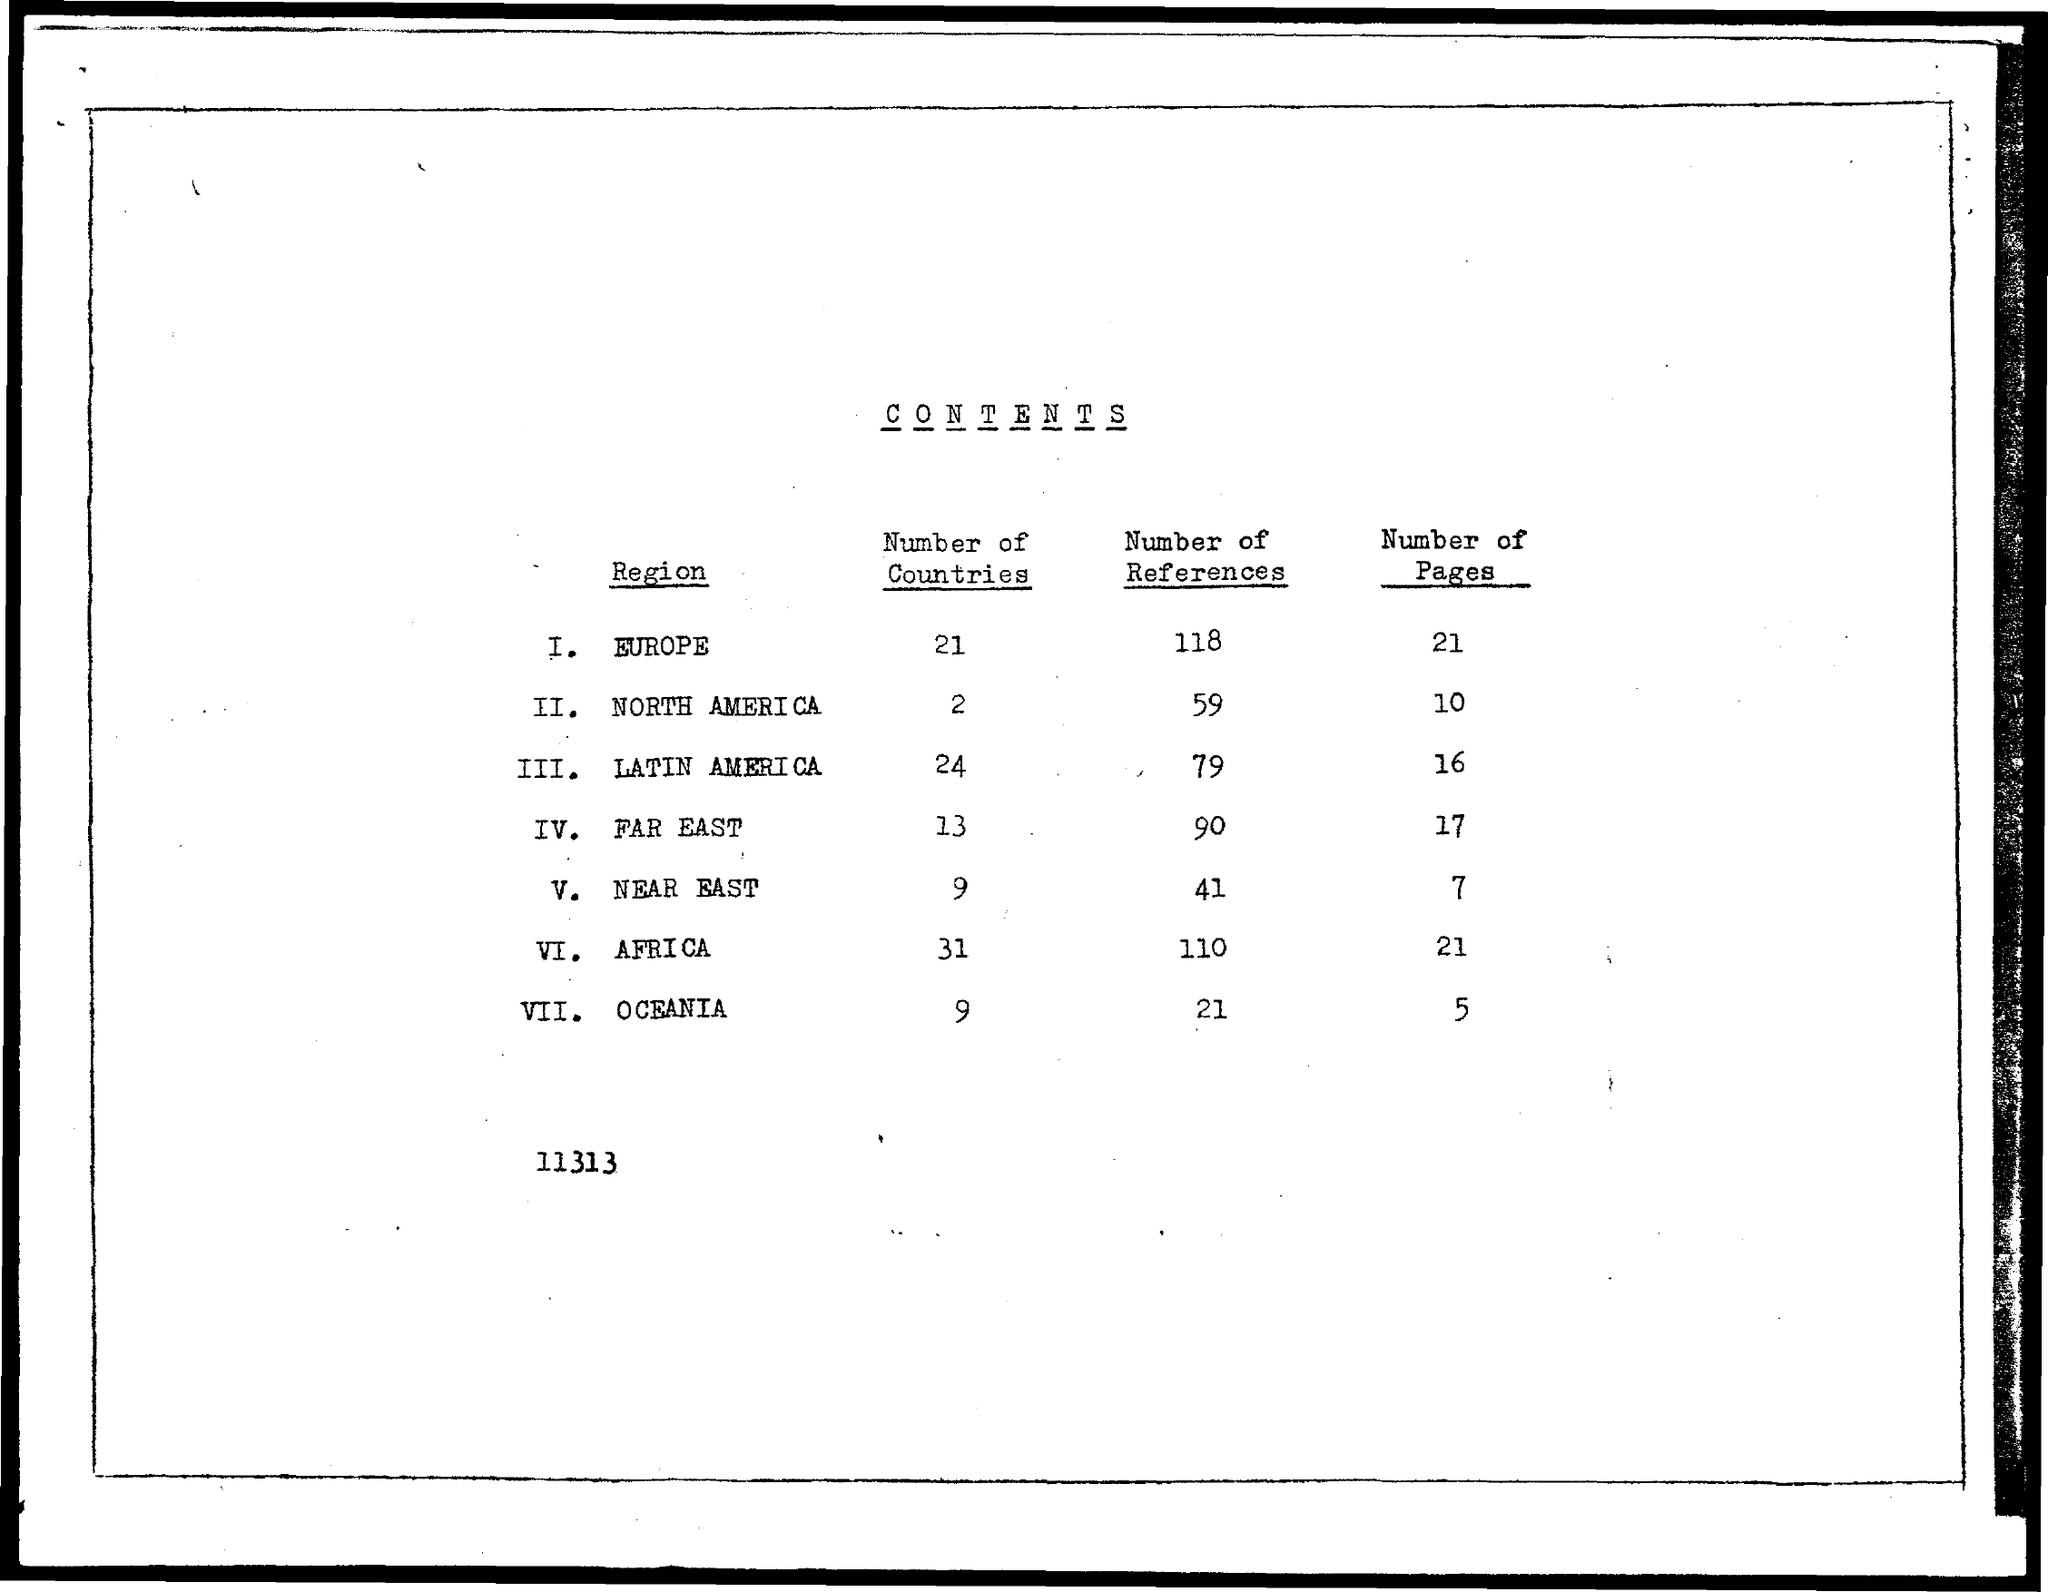What are the Number of References for Europe?
Provide a short and direct response. 118. What are the Number of References for North America?
Offer a terse response. 59. What are the Number of References for Latin America?
Your answer should be very brief. 79. What are the Number of References for Far East?
Offer a very short reply. 90. What are the Number of References for Near East?
Make the answer very short. 41. What are the Number of References for Africa?
Provide a short and direct response. 110. What are the Number of References for Oceania?
Offer a terse response. 21. What are the Number of Countries for Europe?
Your response must be concise. 21. What are the Number of Countries for North America?
Give a very brief answer. 2. What are the Number of Countries for Latin America?
Give a very brief answer. 24. 